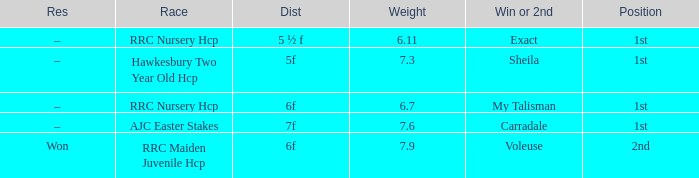What was the distance when the weight was 6.11? 5 ½ f. 